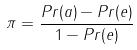<formula> <loc_0><loc_0><loc_500><loc_500>\pi = \frac { P r ( a ) - P r ( e ) } { 1 - P r ( e ) }</formula> 